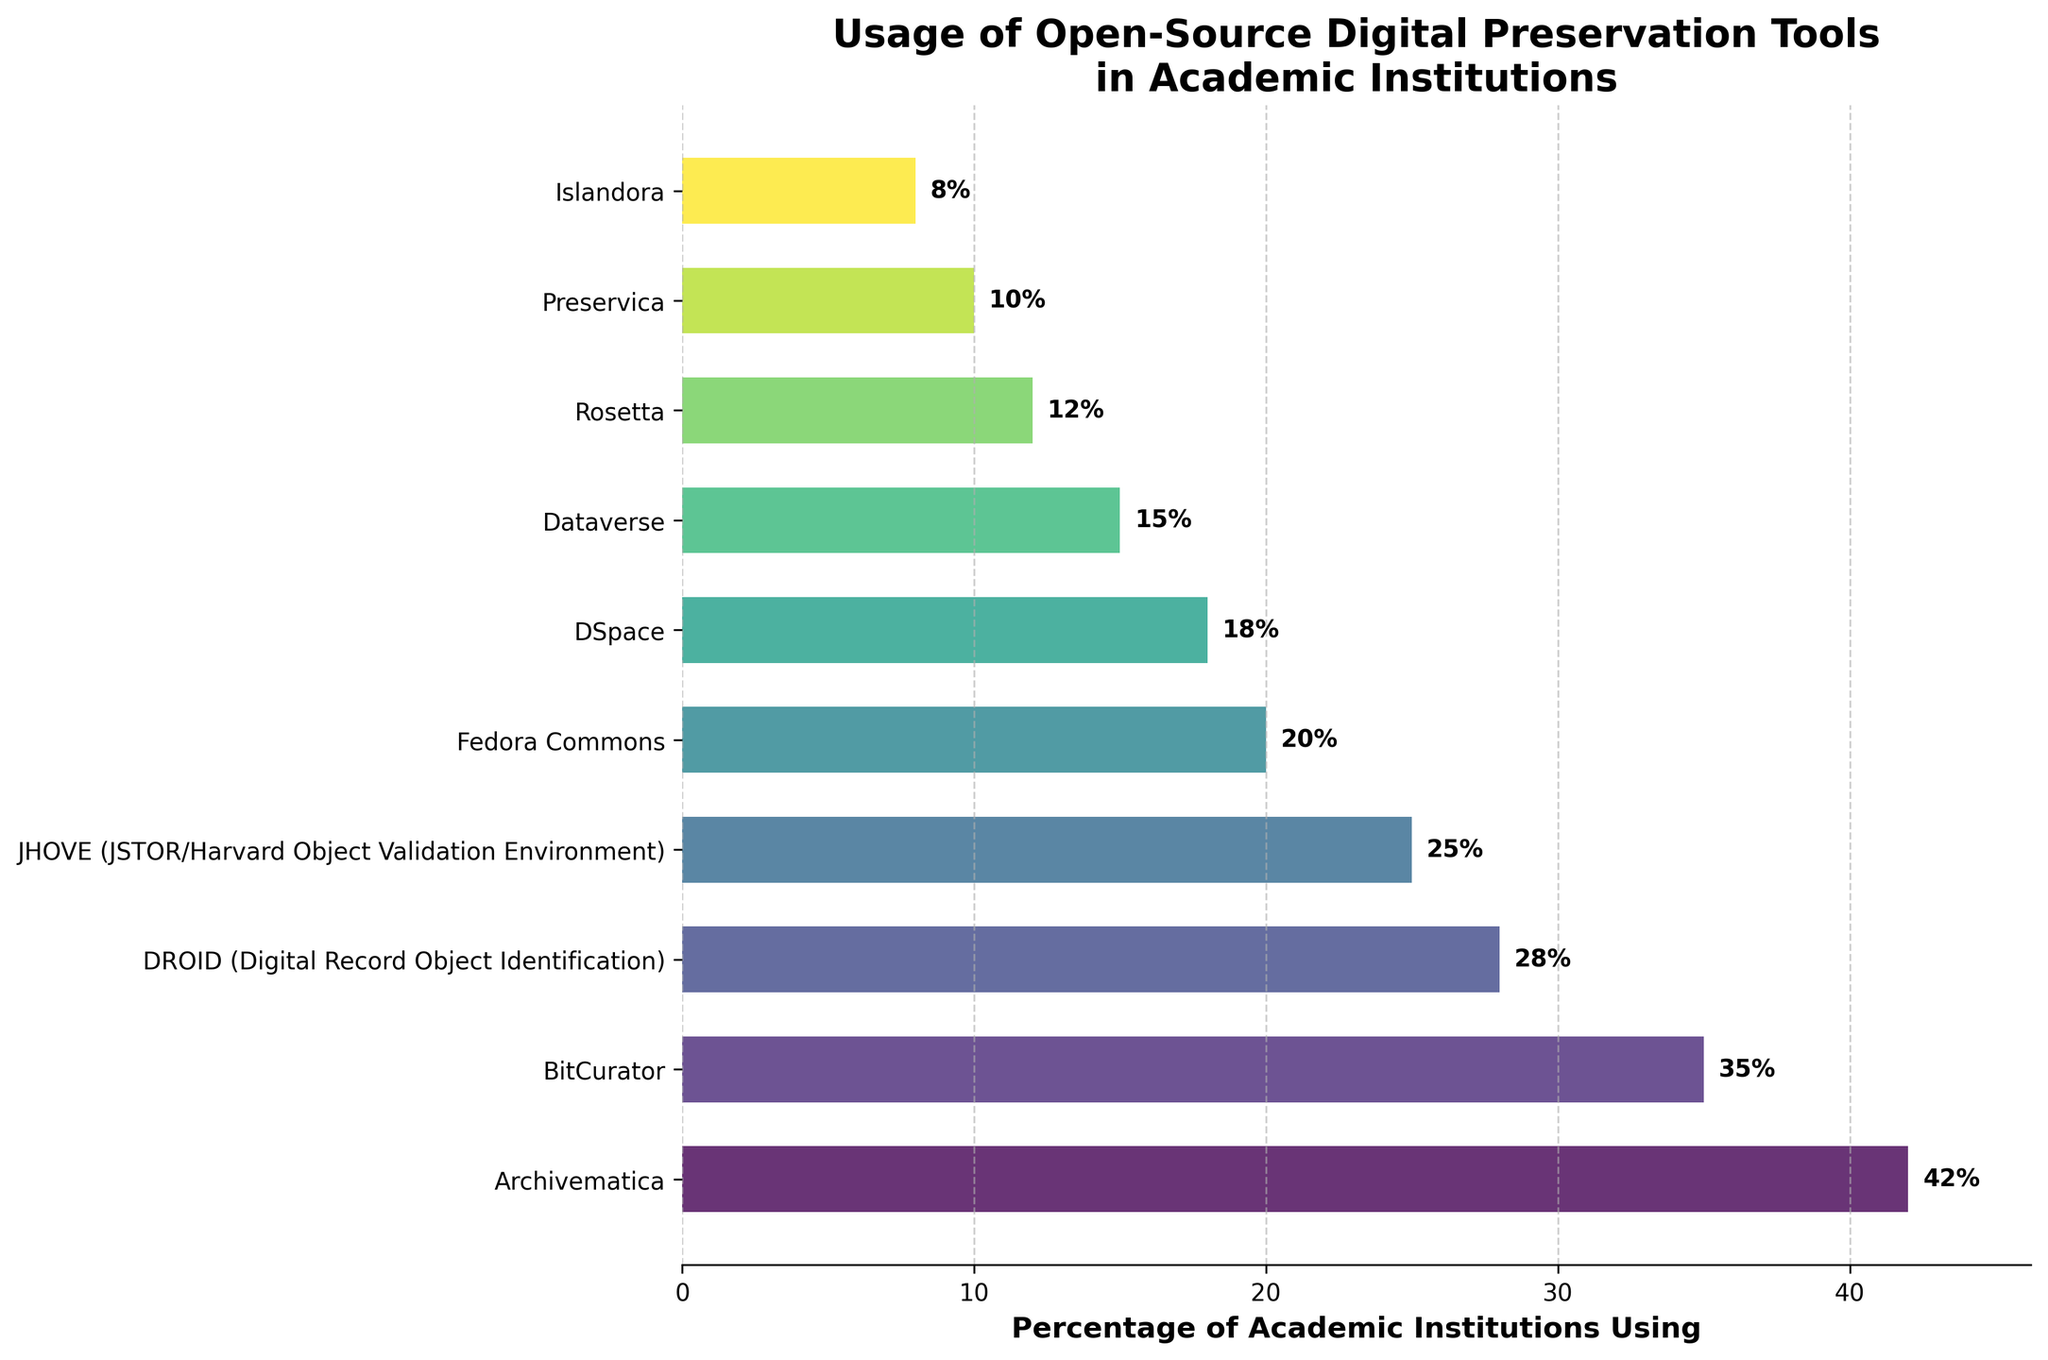Which tool is used by the highest percentage of academic institutions? The bar representing the 'Archivematica' tool is the longest, indicating the highest percentage.
Answer: Archivematica Which tool has the lowest usage among academic institutions? The bar for 'Islandora' is the shortest, indicating the lowest usage percentage.
Answer: Islandora How much higher is the percentage of institutions using Archivematica compared to those using Preservica? The percentage for Archivematica is 42% and for Preservica is 10%. The difference is calculated as 42% - 10%.
Answer: 32% What is the combined percentage of academic institutions using DROID and JHOVE? The percentages for DROID and JHOVE are 28% and 25%, respectively. The combined percentage is 28% + 25%.
Answer: 53% Which tools are used by more than 30% of academic institutions? The bars for Archivematica (42%) and BitCurator (35%) extend beyond the 30% mark.
Answer: Archivematica, BitCurator Are there more institutions using DSpace than Dataverse? Comparing the bar lengths for DSpace (18%) and Dataverse (15%), the bar for DSpace is longer.
Answer: Yes Which three tools have usage percentages between 10% and 20%? The bars for Fedora Commons (20%), DSpace (18%), and Dataverse (15%) fall within the 10% to 20% range.
Answer: Fedora Commons, DSpace, Dataverse What is the average usage percentage of the tools listed? Sum all usage percentages (42 + 35 + 28 + 25 + 20 + 18 + 15 + 12 + 10 + 8) = 213; divide by the number of tools (10).
Answer: 21.3% Is BitCurator used by more academic institutions than JHOVE? The percentage for BitCurator (35%) is higher than that for JHOVE (25%).
Answer: Yes How much less is the usage percentage of Islandora compared to Fedora Commons? The percentage for Islandora is 8% and for Fedora Commons is 20%. The difference is calculated as 20% - 8%.
Answer: 12% 